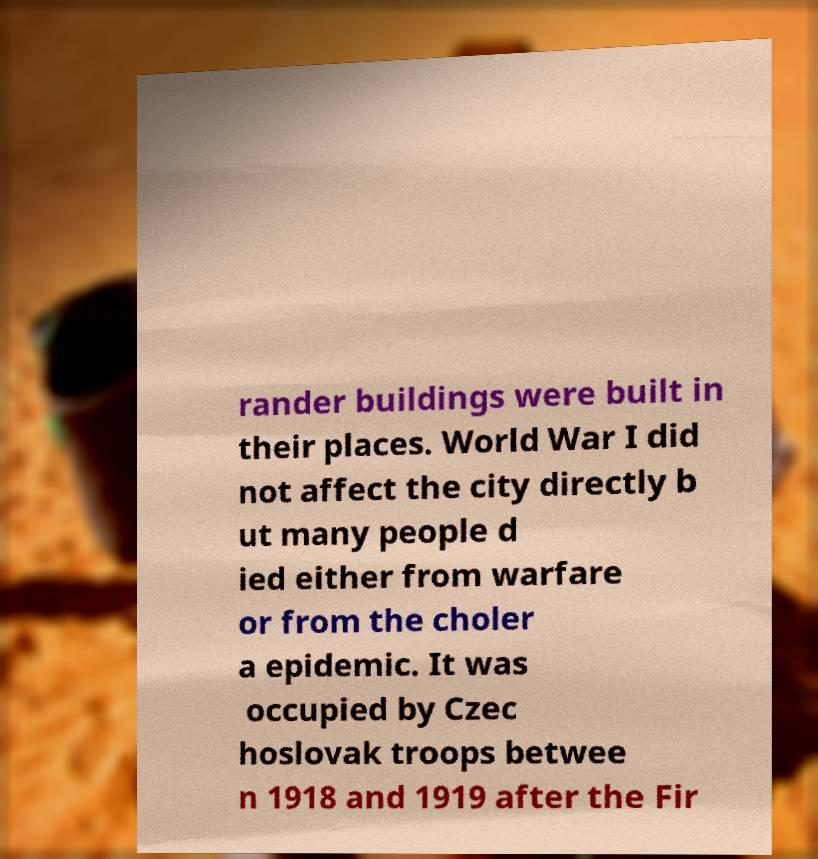What messages or text are displayed in this image? I need them in a readable, typed format. rander buildings were built in their places. World War I did not affect the city directly b ut many people d ied either from warfare or from the choler a epidemic. It was occupied by Czec hoslovak troops betwee n 1918 and 1919 after the Fir 